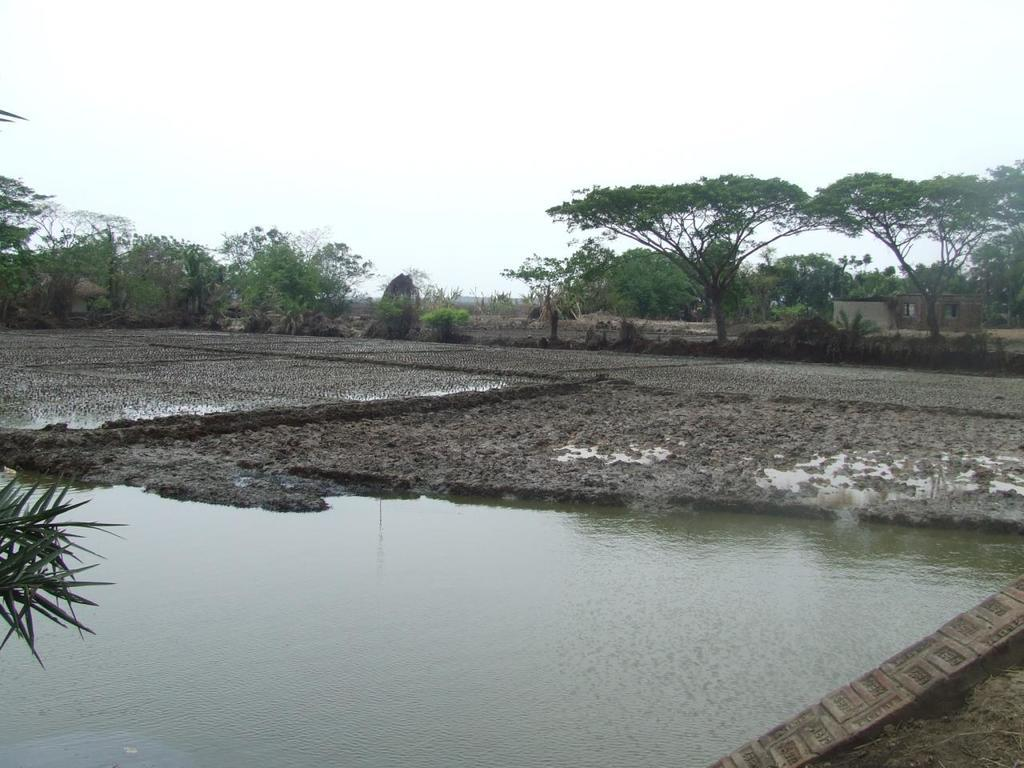What is present at the bottom of the image? There is water at the bottom of the image. What can be seen in the middle of the image? There are trees and mud in the middle of the image. What is visible at the top of the image? The sky is visible at the top of the image. Can you see a match being lit in the image? There is no match or any indication of fire in the image. What type of potato is growing in the middle of the image? There are no potatoes present in the image; it features trees and mud. 